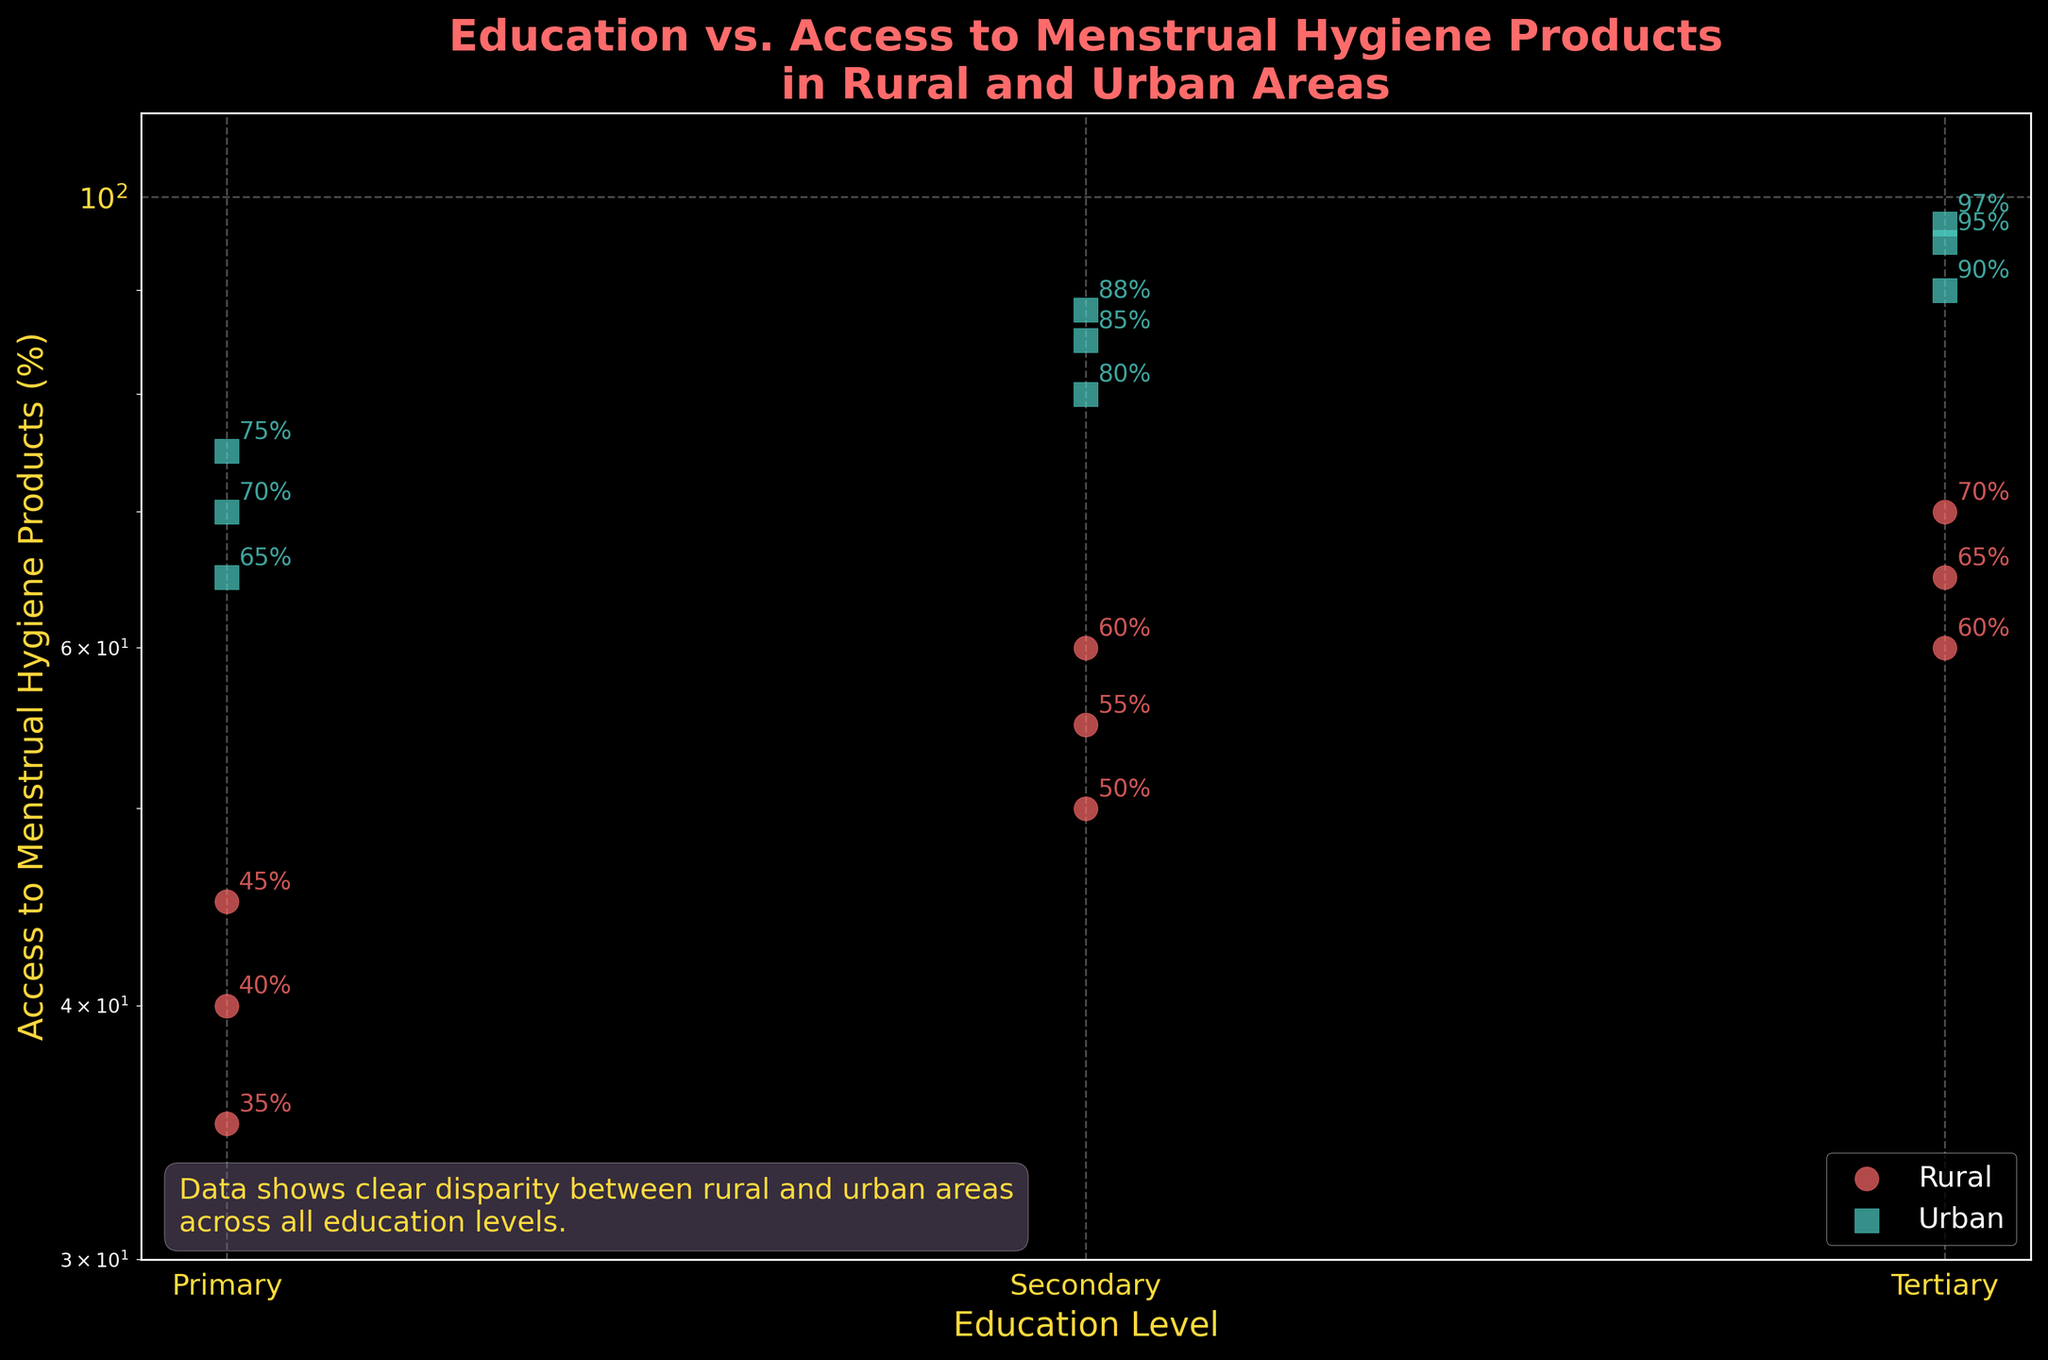What is the title of the plot? The title is displayed at the top of the figure in a bold font. It summarizes the theme of the data. The title reads "Education vs. Access to Menstrual Hygiene Products in Rural and Urban Areas".
Answer: Education vs. Access to Menstrual Hygiene Products in Rural and Urban Areas What are the colors used for the data points representing rural and urban areas? The scatter plot uses different colors for rural and urban data points to distinguish them. Rural areas are represented by red circles, while urban areas are represented by teal squares.
Answer: Red circles and teal squares How many data points represent tertiary education levels in urban areas? The data points for each education level in urban areas are represented by teal squares. Count the number of teal squares aligned with the 'Tertiary' level. There are three such data points.
Answer: Three What is the range of access to menstrual hygiene products for primary education in rural areas? By looking at the red circles representing rural areas at the 'Primary' education level on the x-axis and checking their corresponding values on the y-axis, the access rates range from 35% to 45%.
Answer: 35% to 45% Is there any annotation indicating data points in the plot? The plot has text labels next to each data point that show the percentage values of access to menstrual hygiene products. Each annotation indicates the exact percentage corresponding to each data point.
Answer: Yes What is the average percentage of access to menstrual hygiene products for secondary education in rural areas? Identify the red circles corresponding to 'Secondary' on the x-axis and note their y-values (55%, 50%, 60%). Sum up these values and divide by the number of data points: (55 + 50 + 60) / 3 = 165 / 3 = 55.
Answer: 55% Which area has more access to menstrual hygiene products for tertiary education, rural or urban areas? Compare the average access rates between rural and urban areas at the tertiary education level. Urban areas (95%, 90%, 97%) have consistently higher values than rural areas (65%, 60%, 70%).
Answer: Urban What do the log scale y-axis help visualize in this scatter plot? The log scale on the y-axis helps compress the range of percentage values, making disparities in access between rural and urban areas clearer and easier to compare visually.
Answer: Disparities in access What is the trend of access to menstrual hygiene products as education levels increase in urban areas? Observe the aligned teal squares as education levels increase from 'Primary' to 'Tertiary'. The percentages increase from 'Primary' (70%, 65%, 75%) to 'Tertiary' (95%, 90%, 97%). This indicates a positive trend where higher education correlates with higher access.
Answer: Positive trend What does the text box in the bottom left corner summarize about the plot? The text box in the bottom left corner of the plot provides a summary of the data, emphasizing the disparity in access to menstrual hygiene products between rural and urban areas across education levels.
Answer: Disparity between rural and urban areas 